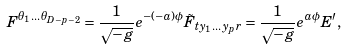Convert formula to latex. <formula><loc_0><loc_0><loc_500><loc_500>F ^ { \theta _ { 1 } \dots \theta _ { D - p - 2 } } = \frac { 1 } { \sqrt { - g } } e ^ { - ( - a ) \phi } \tilde { F } _ { t y _ { 1 } \dots y _ { p } r } = \frac { 1 } { \sqrt { - g } } e ^ { a \phi } E ^ { \prime } ,</formula> 